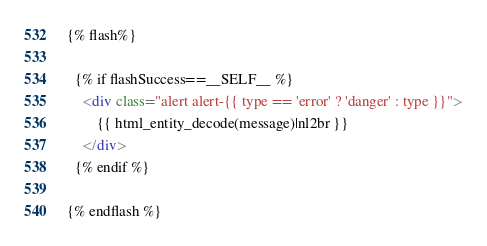<code> <loc_0><loc_0><loc_500><loc_500><_HTML_>{% flash%}

  {% if flashSuccess==__SELF__ %}
  	<div class="alert alert-{{ type == 'error' ? 'danger' : type }}">
  		{{ html_entity_decode(message)|nl2br }}
  	</div>
  {% endif %}

{% endflash %}
</code> 